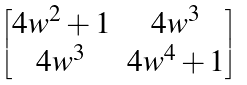<formula> <loc_0><loc_0><loc_500><loc_500>\begin{bmatrix} 4 w ^ { 2 } + 1 & 4 w ^ { 3 } \\ 4 w ^ { 3 } & 4 w ^ { 4 } + 1 \end{bmatrix}</formula> 